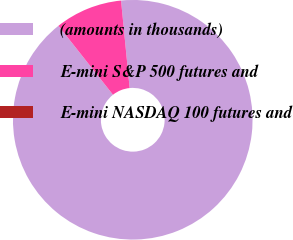Convert chart. <chart><loc_0><loc_0><loc_500><loc_500><pie_chart><fcel>(amounts in thousands)<fcel>E-mini S&P 500 futures and<fcel>E-mini NASDAQ 100 futures and<nl><fcel>90.91%<fcel>9.09%<fcel>0.0%<nl></chart> 